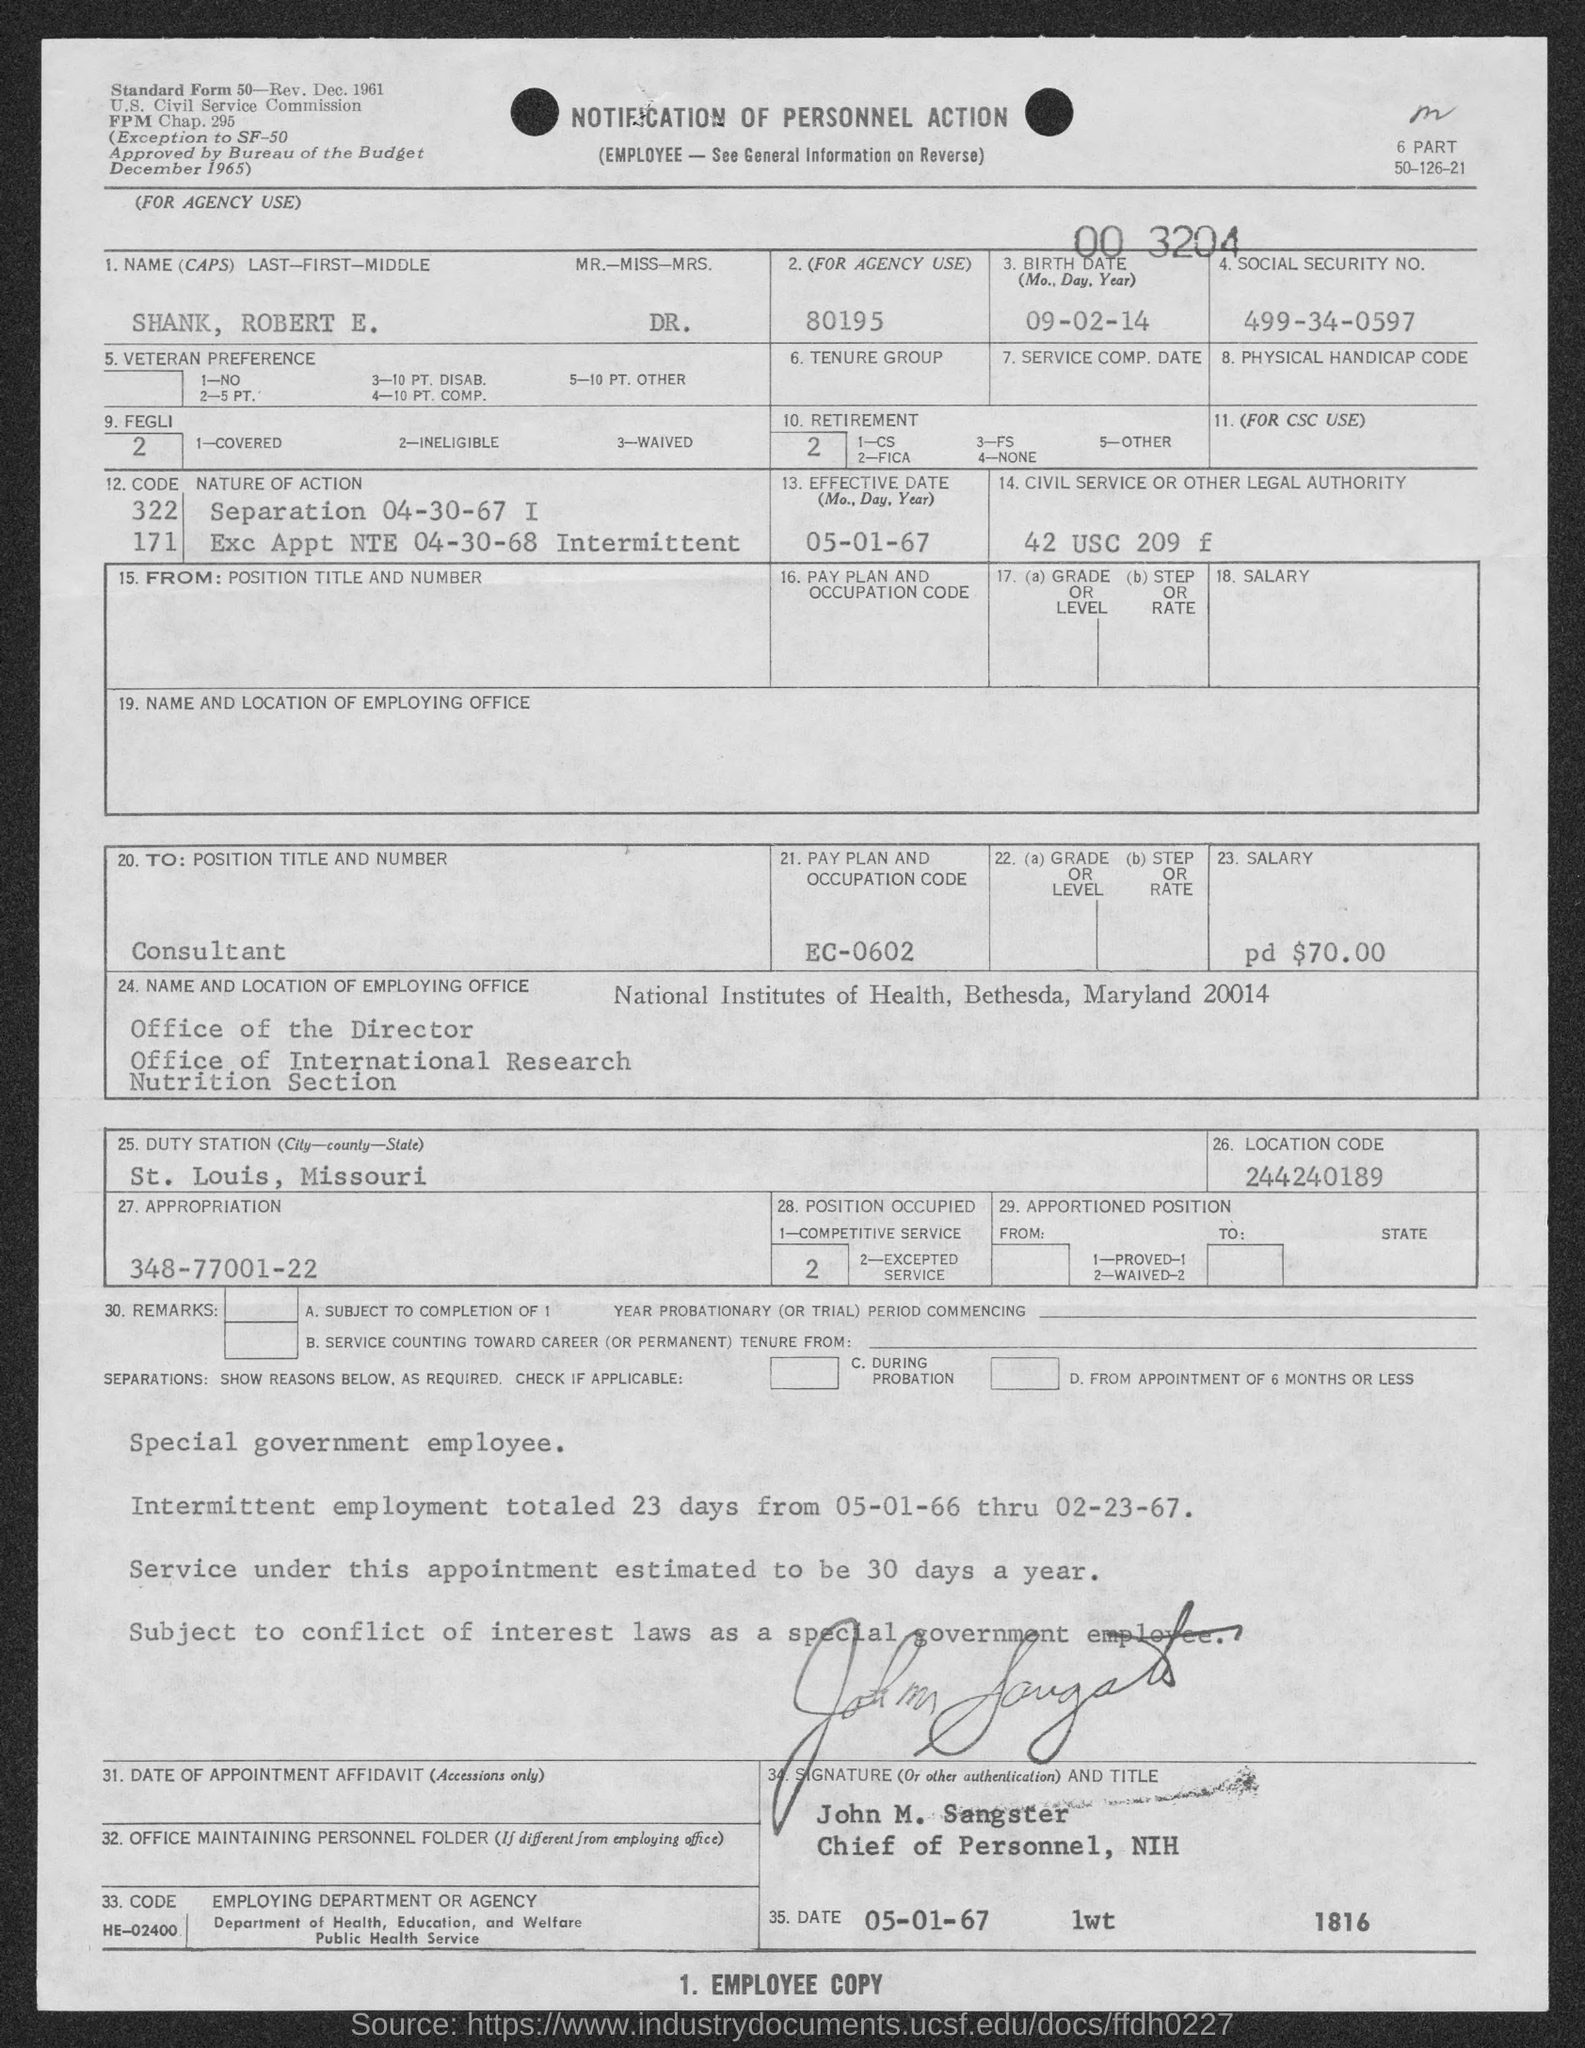Give some essential details in this illustration. This notification pertains to a Personnel Action. The name of the person who is in charge of the Personnel department at the National Institutes of Health is John M. Sangster. The pay plan and occupation code EC-0602 refer to a specific system for determining compensation and job classifications. The date on which the document is signed is January 5, 1967. At the bottom of the page, there is written "1. Employee copy. 